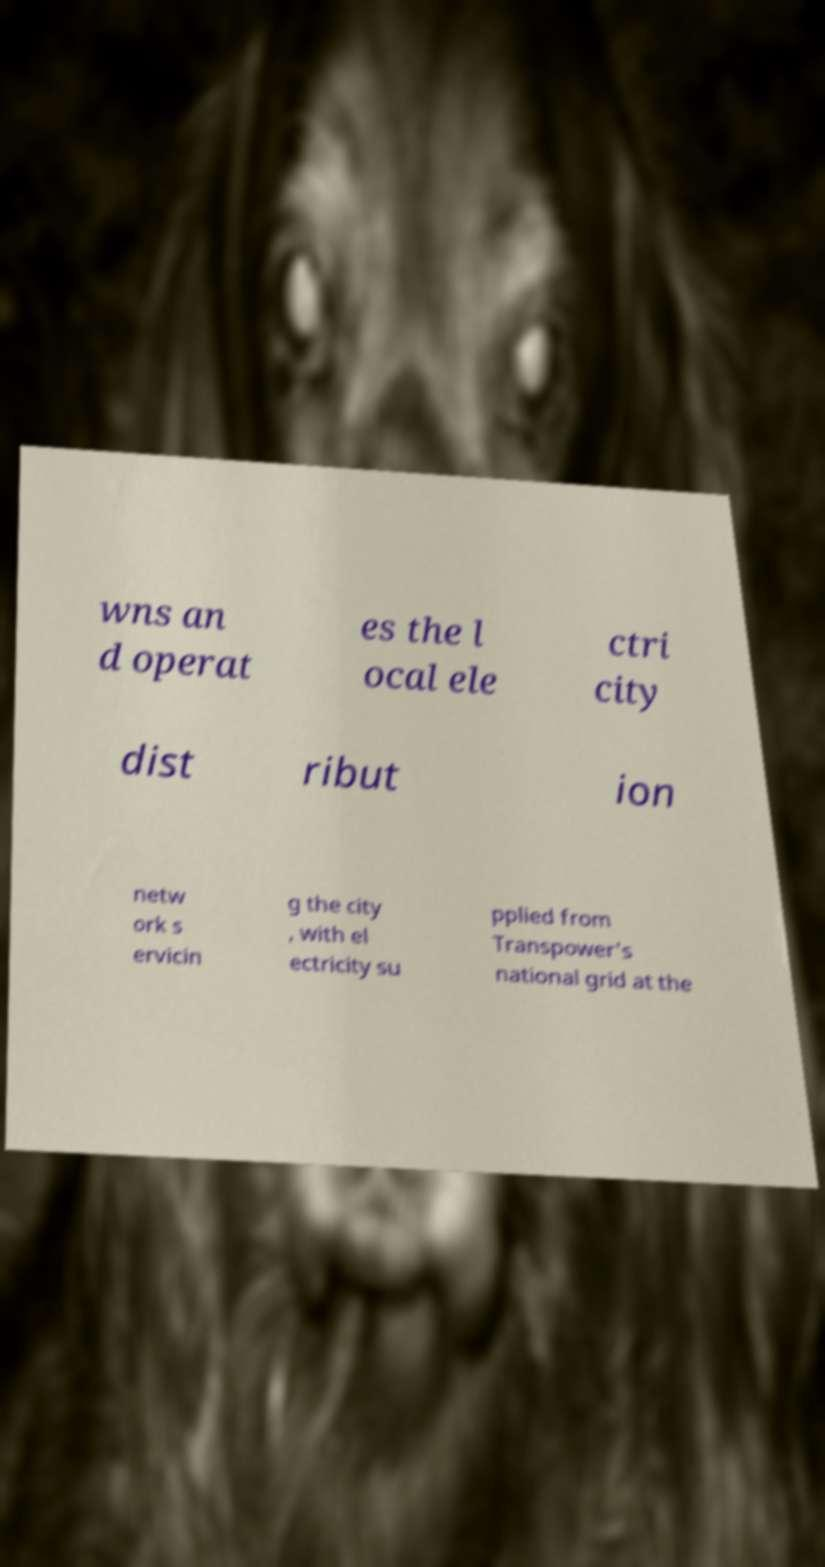Could you extract and type out the text from this image? wns an d operat es the l ocal ele ctri city dist ribut ion netw ork s ervicin g the city , with el ectricity su pplied from Transpower's national grid at the 